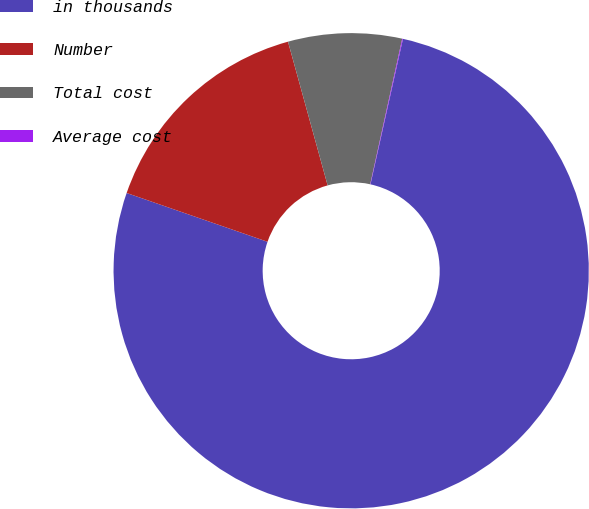Convert chart to OTSL. <chart><loc_0><loc_0><loc_500><loc_500><pie_chart><fcel>in thousands<fcel>Number<fcel>Total cost<fcel>Average cost<nl><fcel>76.81%<fcel>15.41%<fcel>7.73%<fcel>0.05%<nl></chart> 